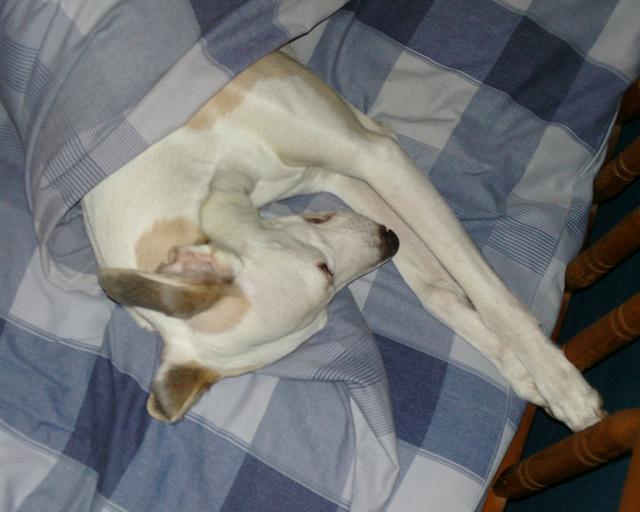Is this dog tired?
Short answer required. Yes. Are each of the objects shown in the image cleaned/washed with the same cleaning product?
Keep it brief. No. Is the dog awake?
Short answer required. No. 